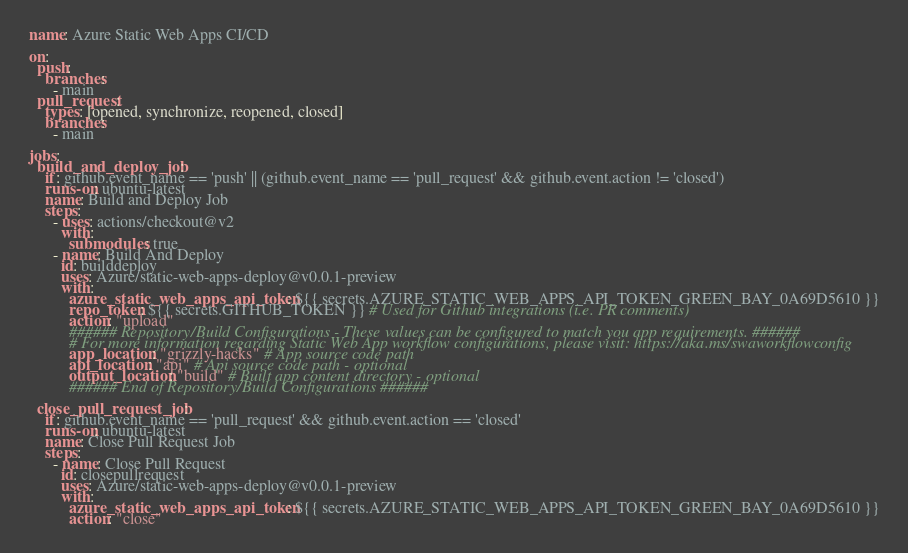<code> <loc_0><loc_0><loc_500><loc_500><_YAML_>name: Azure Static Web Apps CI/CD

on:
  push:
    branches:
      - main
  pull_request:
    types: [opened, synchronize, reopened, closed]
    branches:
      - main

jobs:
  build_and_deploy_job:
    if: github.event_name == 'push' || (github.event_name == 'pull_request' && github.event.action != 'closed')
    runs-on: ubuntu-latest
    name: Build and Deploy Job
    steps:
      - uses: actions/checkout@v2
        with:
          submodules: true
      - name: Build And Deploy
        id: builddeploy
        uses: Azure/static-web-apps-deploy@v0.0.1-preview
        with:
          azure_static_web_apps_api_token: ${{ secrets.AZURE_STATIC_WEB_APPS_API_TOKEN_GREEN_BAY_0A69D5610 }}
          repo_token: ${{ secrets.GITHUB_TOKEN }} # Used for Github integrations (i.e. PR comments)
          action: "upload"
          ###### Repository/Build Configurations - These values can be configured to match you app requirements. ######
          # For more information regarding Static Web App workflow configurations, please visit: https://aka.ms/swaworkflowconfig
          app_location: "grizzly-hacks" # App source code path
          api_location: "api" # Api source code path - optional
          output_location: "build" # Built app content directory - optional
          ###### End of Repository/Build Configurations ######

  close_pull_request_job:
    if: github.event_name == 'pull_request' && github.event.action == 'closed'
    runs-on: ubuntu-latest
    name: Close Pull Request Job
    steps:
      - name: Close Pull Request
        id: closepullrequest
        uses: Azure/static-web-apps-deploy@v0.0.1-preview
        with:
          azure_static_web_apps_api_token: ${{ secrets.AZURE_STATIC_WEB_APPS_API_TOKEN_GREEN_BAY_0A69D5610 }}
          action: "close"
</code> 